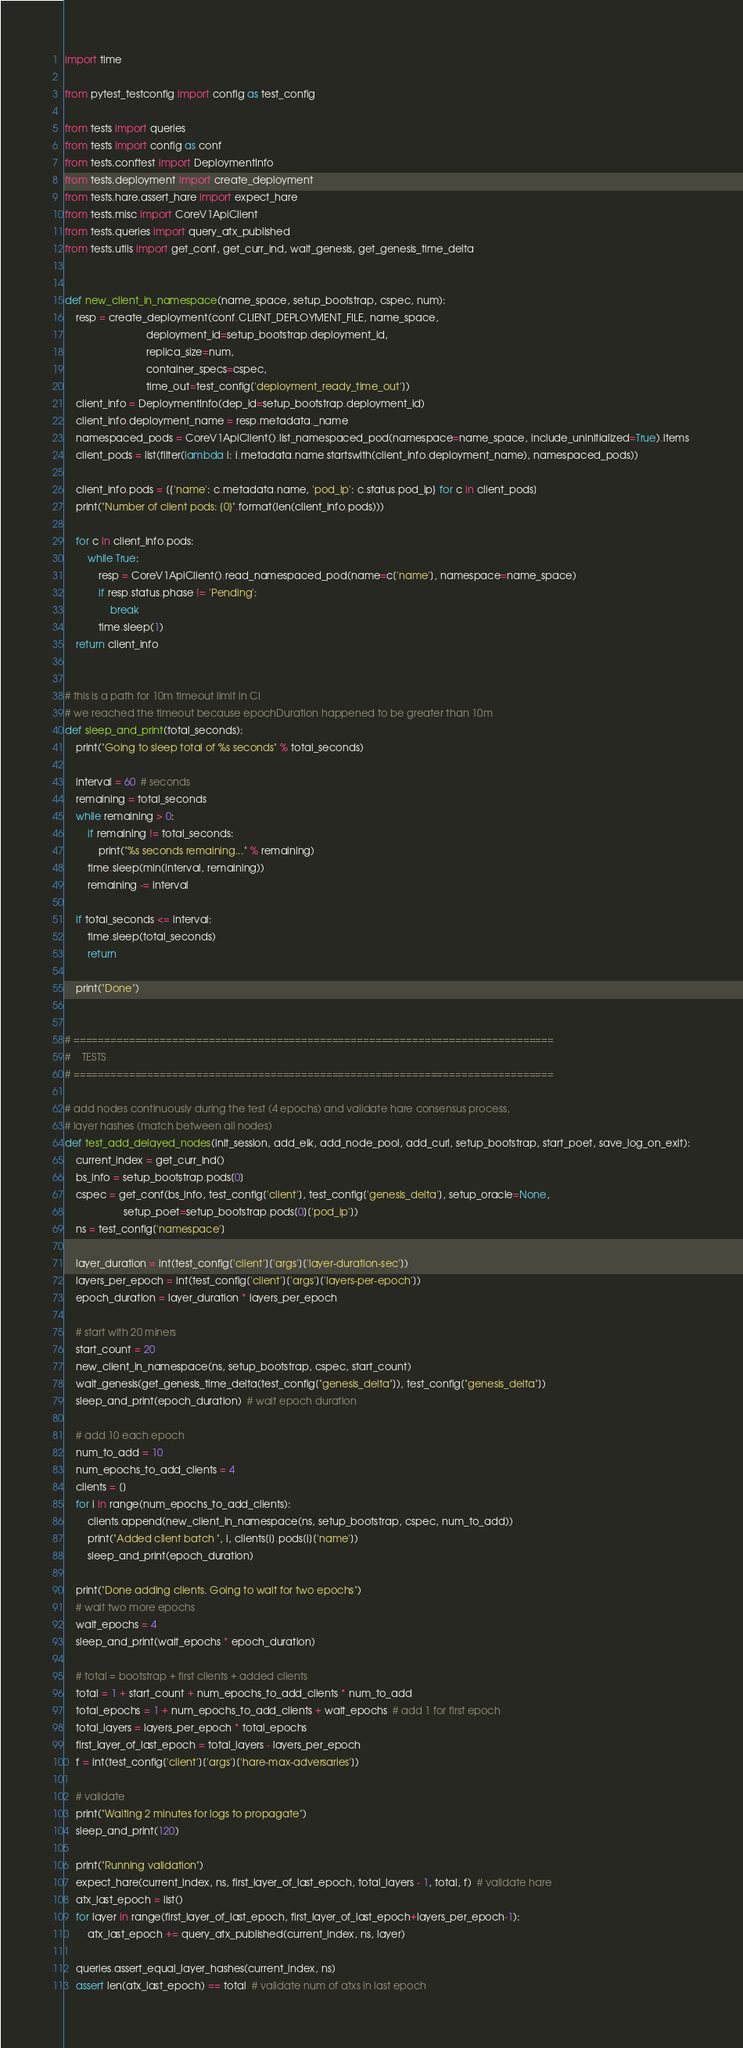Convert code to text. <code><loc_0><loc_0><loc_500><loc_500><_Python_>import time

from pytest_testconfig import config as test_config

from tests import queries
from tests import config as conf
from tests.conftest import DeploymentInfo
from tests.deployment import create_deployment
from tests.hare.assert_hare import expect_hare
from tests.misc import CoreV1ApiClient
from tests.queries import query_atx_published
from tests.utils import get_conf, get_curr_ind, wait_genesis, get_genesis_time_delta


def new_client_in_namespace(name_space, setup_bootstrap, cspec, num):
    resp = create_deployment(conf.CLIENT_DEPLOYMENT_FILE, name_space,
                             deployment_id=setup_bootstrap.deployment_id,
                             replica_size=num,
                             container_specs=cspec,
                             time_out=test_config['deployment_ready_time_out'])
    client_info = DeploymentInfo(dep_id=setup_bootstrap.deployment_id)
    client_info.deployment_name = resp.metadata._name
    namespaced_pods = CoreV1ApiClient().list_namespaced_pod(namespace=name_space, include_uninitialized=True).items
    client_pods = list(filter(lambda i: i.metadata.name.startswith(client_info.deployment_name), namespaced_pods))

    client_info.pods = [{'name': c.metadata.name, 'pod_ip': c.status.pod_ip} for c in client_pods]
    print("Number of client pods: {0}".format(len(client_info.pods)))

    for c in client_info.pods:
        while True:
            resp = CoreV1ApiClient().read_namespaced_pod(name=c['name'], namespace=name_space)
            if resp.status.phase != 'Pending':
                break
            time.sleep(1)
    return client_info


# this is a path for 10m timeout limit in CI
# we reached the timeout because epochDuration happened to be greater than 10m
def sleep_and_print(total_seconds):
    print("Going to sleep total of %s seconds" % total_seconds)

    interval = 60  # seconds
    remaining = total_seconds
    while remaining > 0:
        if remaining != total_seconds:
            print("%s seconds remaining..." % remaining)
        time.sleep(min(interval, remaining))
        remaining -= interval

    if total_seconds <= interval:
        time.sleep(total_seconds)
        return

    print("Done")


# ==============================================================================
#    TESTS
# ==============================================================================

# add nodes continuously during the test (4 epochs) and validate hare consensus process,
# layer hashes (match between all nodes)
def test_add_delayed_nodes(init_session, add_elk, add_node_pool, add_curl, setup_bootstrap, start_poet, save_log_on_exit):
    current_index = get_curr_ind()
    bs_info = setup_bootstrap.pods[0]
    cspec = get_conf(bs_info, test_config['client'], test_config['genesis_delta'], setup_oracle=None,
                     setup_poet=setup_bootstrap.pods[0]['pod_ip'])
    ns = test_config['namespace']

    layer_duration = int(test_config['client']['args']['layer-duration-sec'])
    layers_per_epoch = int(test_config['client']['args']['layers-per-epoch'])
    epoch_duration = layer_duration * layers_per_epoch

    # start with 20 miners
    start_count = 20
    new_client_in_namespace(ns, setup_bootstrap, cspec, start_count)
    wait_genesis(get_genesis_time_delta(test_config["genesis_delta"]), test_config["genesis_delta"])
    sleep_and_print(epoch_duration)  # wait epoch duration

    # add 10 each epoch
    num_to_add = 10
    num_epochs_to_add_clients = 4
    clients = []
    for i in range(num_epochs_to_add_clients):
        clients.append(new_client_in_namespace(ns, setup_bootstrap, cspec, num_to_add))
        print("Added client batch ", i, clients[i].pods[i]['name'])
        sleep_and_print(epoch_duration)

    print("Done adding clients. Going to wait for two epochs")
    # wait two more epochs
    wait_epochs = 4
    sleep_and_print(wait_epochs * epoch_duration)

    # total = bootstrap + first clients + added clients
    total = 1 + start_count + num_epochs_to_add_clients * num_to_add
    total_epochs = 1 + num_epochs_to_add_clients + wait_epochs  # add 1 for first epoch
    total_layers = layers_per_epoch * total_epochs
    first_layer_of_last_epoch = total_layers - layers_per_epoch
    f = int(test_config['client']['args']['hare-max-adversaries'])

    # validate
    print("Waiting 2 minutes for logs to propagate")
    sleep_and_print(120)

    print("Running validation")
    expect_hare(current_index, ns, first_layer_of_last_epoch, total_layers - 1, total, f)  # validate hare
    atx_last_epoch = list()
    for layer in range(first_layer_of_last_epoch, first_layer_of_last_epoch+layers_per_epoch-1):
        atx_last_epoch += query_atx_published(current_index, ns, layer)

    queries.assert_equal_layer_hashes(current_index, ns)
    assert len(atx_last_epoch) == total  # validate num of atxs in last epoch
</code> 